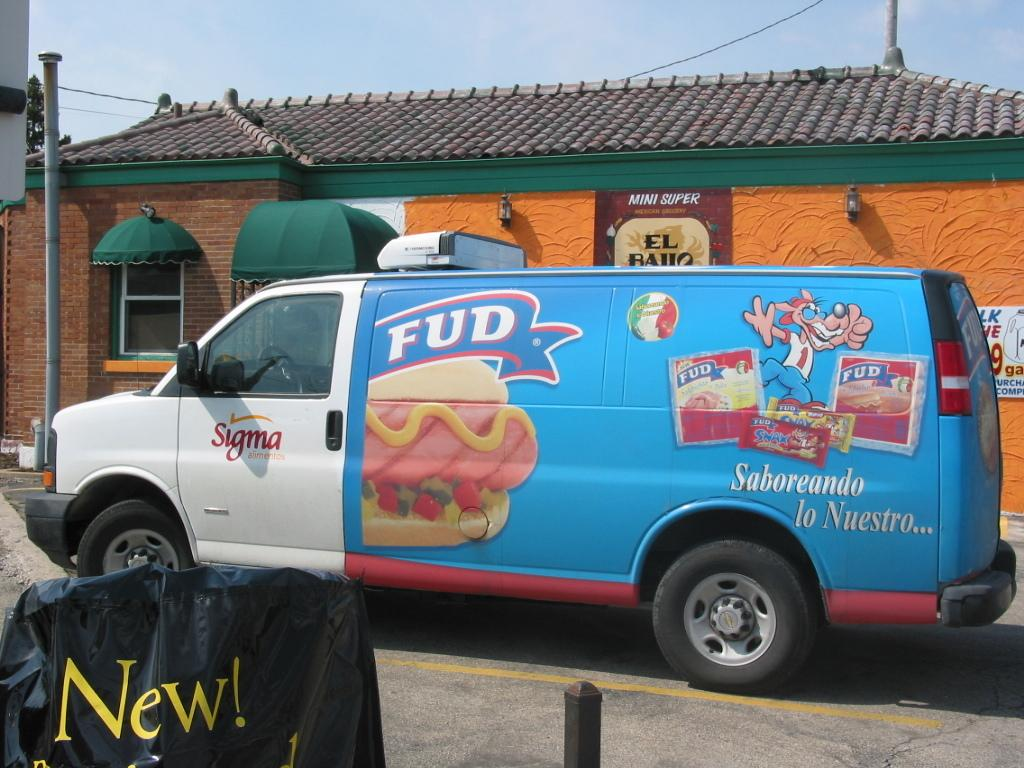<image>
Render a clear and concise summary of the photo. a van that has the letters FUD on it 